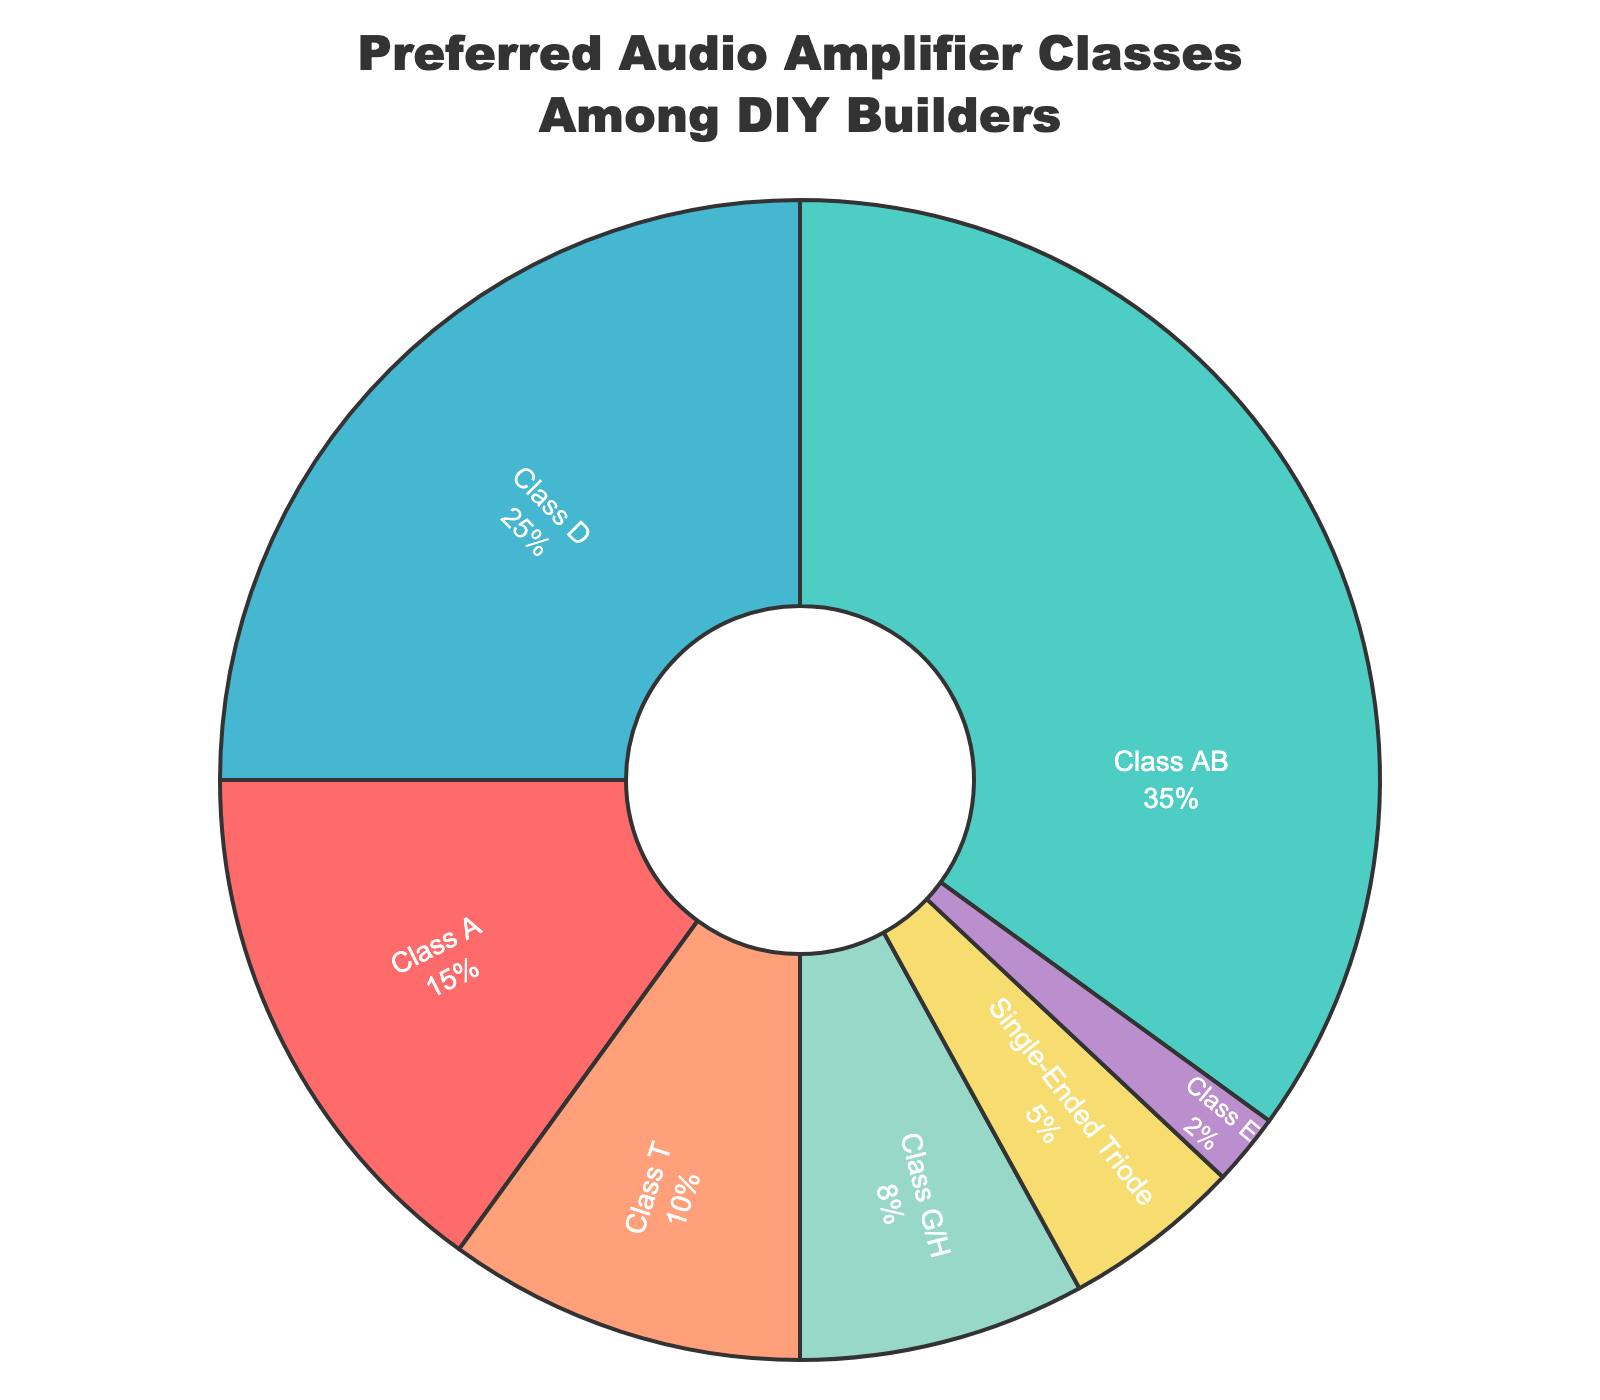What's the most preferred audio amplifier class among DIY builders? The largest segment in the pie chart represents the most preferred audio amplifier class. It shows Class AB with 35%.
Answer: Class AB Which amplifier class is the least preferred among DIY builders? The smallest segment in the pie chart indicates the least preferred amplifier class. It shows Class E with 2%.
Answer: Class E What is the combined preference percentage for Class A and Class D amplifiers? Sum the percentages of Class A (15%) and Class D (25%). 15 + 25 = 40.
Answer: 40% Is Class T more preferred than Single-Ended Triode? Compare the percentages of Class T (10%) and Single-Ended Triode (5%). Class T has a higher percentage.
Answer: Yes What is the difference in preference percentage between Class AB and Class A? Subtract the percentage of Class A (15%) from the percentage of Class AB (35%). 35 - 15 = 20.
Answer: 20% How many amplifier classes have a preference percentage greater than 20%? Identify the segments with percentages greater than 20%. Class AB (35%) and Class D (25%) are the two classes that meet the criterion.
Answer: 2 What is the average preference percentage for Class G/H, Single-Ended Triode, and Class E? Sum the percentages of Class G/H (8%), Single-Ended Triode (5%), and Class E (2%) and divide by the number of classes. (8 + 5 + 2) / 3 = 5.
Answer: 5% Which amplifier class represents the green-colored segment? The pie chart segment in green represents Class AB.
Answer: Class AB Are there more preferences for Class A and Class T combined than for Class D alone? Sum the percentages of Class A (15%) and Class T (10%) and compare with Class D (25%). 15 + 10 = 25, which is equal to 25.
Answer: No What is the total preference percentage for the least preferred three amplifier classes? Sum the percentages of the three smallest segments: Class G/H (8%), Single-Ended Triode (5%), and Class E (2%). 8 + 5 + 2 = 15.
Answer: 15% 